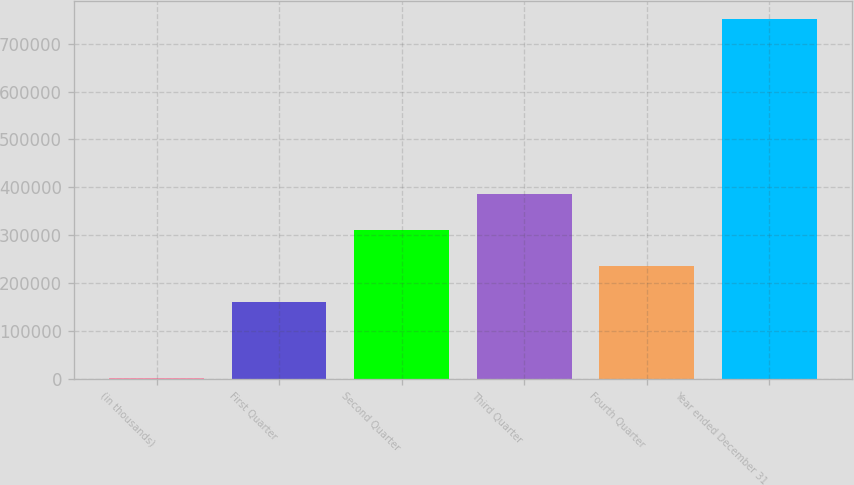<chart> <loc_0><loc_0><loc_500><loc_500><bar_chart><fcel>(in thousands)<fcel>First Quarter<fcel>Second Quarter<fcel>Third Quarter<fcel>Fourth Quarter<fcel>Year ended December 31<nl><fcel>2004<fcel>160416<fcel>310192<fcel>385080<fcel>235304<fcel>750884<nl></chart> 